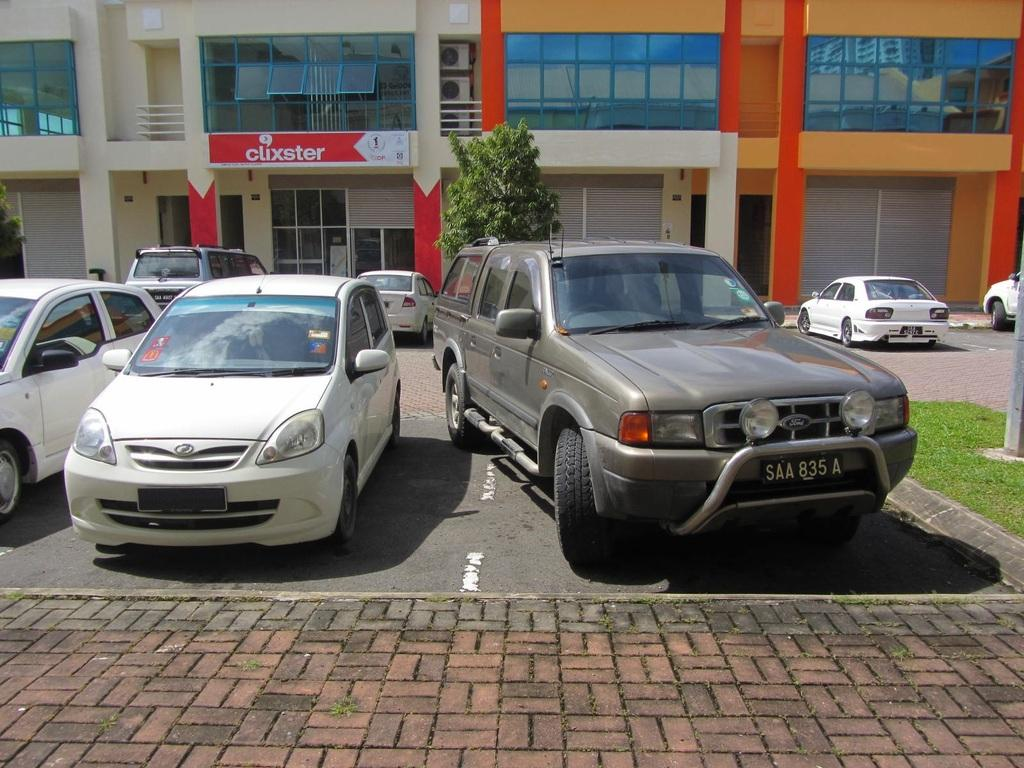What can be seen parked in the image? There are cars parked in the image. What type of structures are visible in the image? There are buildings visible in the image. What is associated with the buildings in the image? There is a board associated with the buildings. What type of vegetation is present in the image? There is a plant in the image. What type of thrill can be experienced by the cars in the image? The cars in the image are parked and not experiencing any thrill. Is there a jail visible in the image? There is no jail present in the image. 